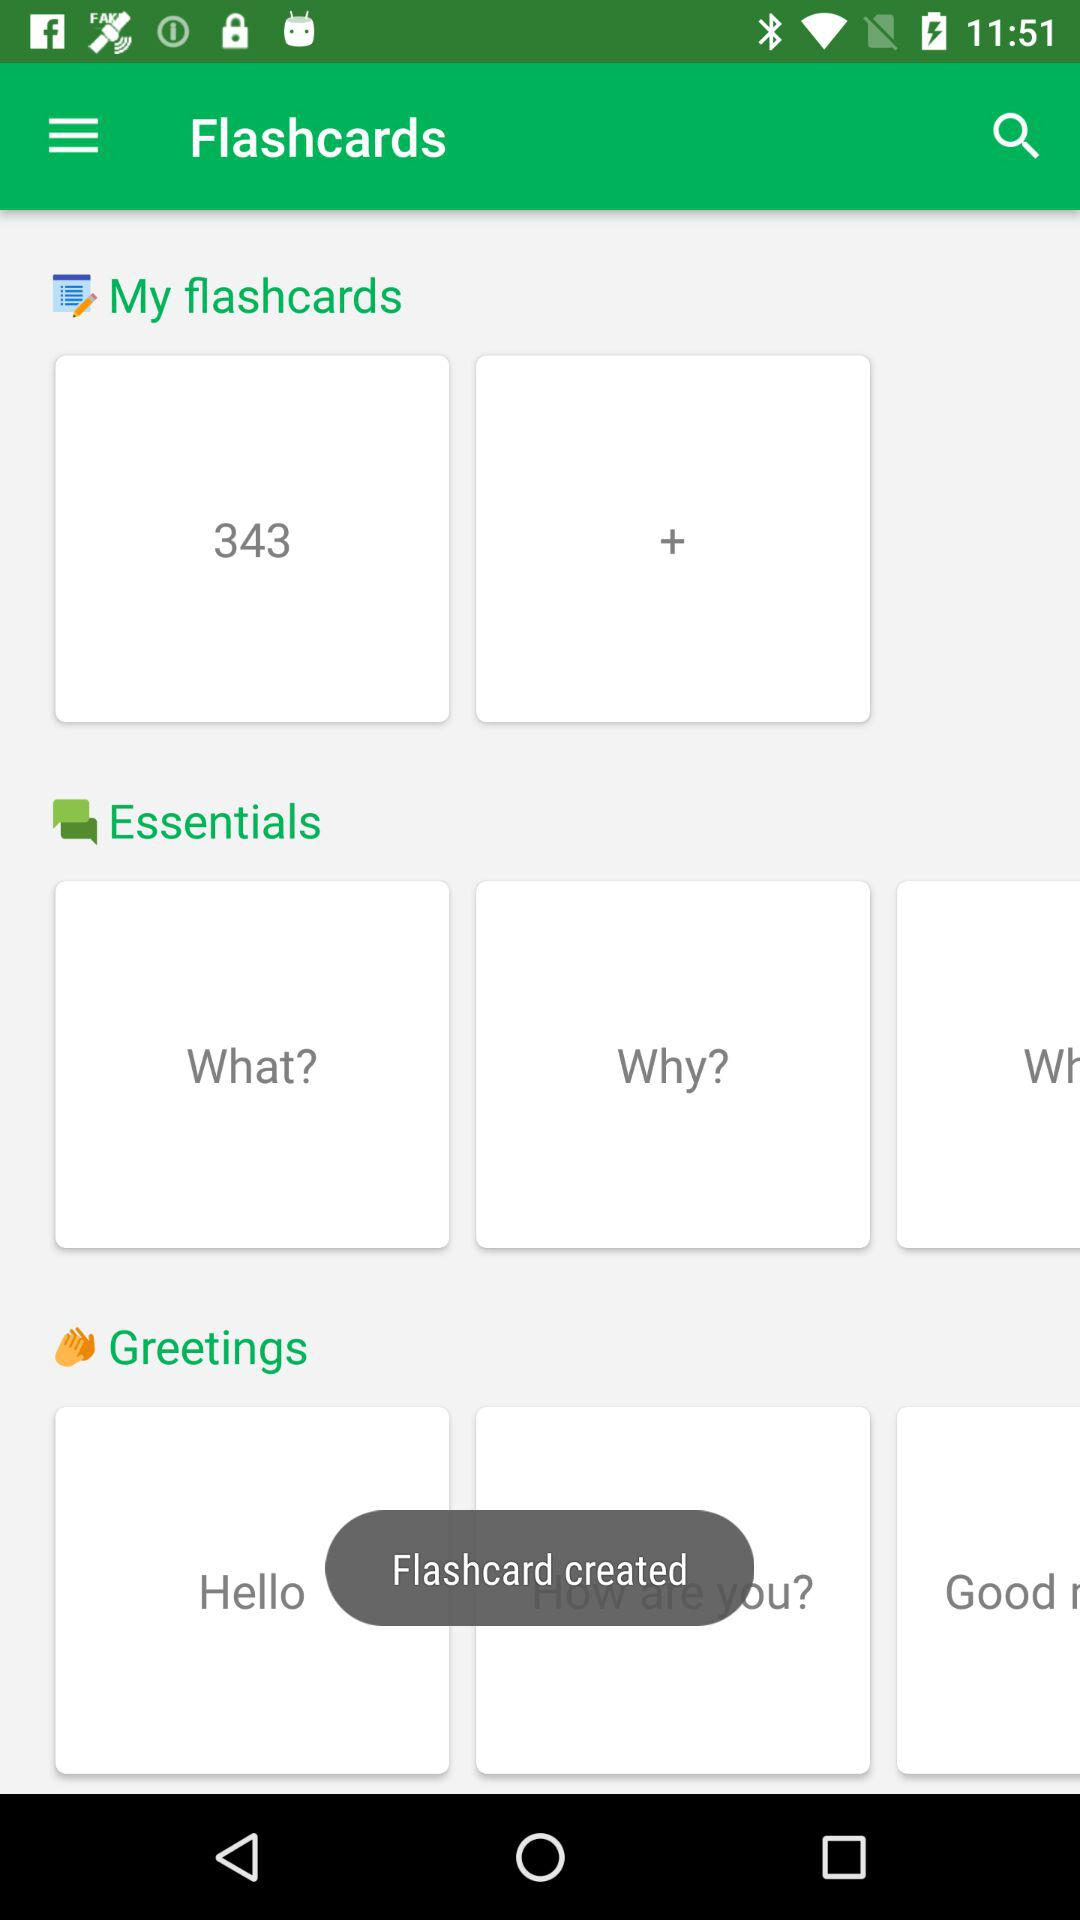How many flashcards are there? There are 343 flashcards. 